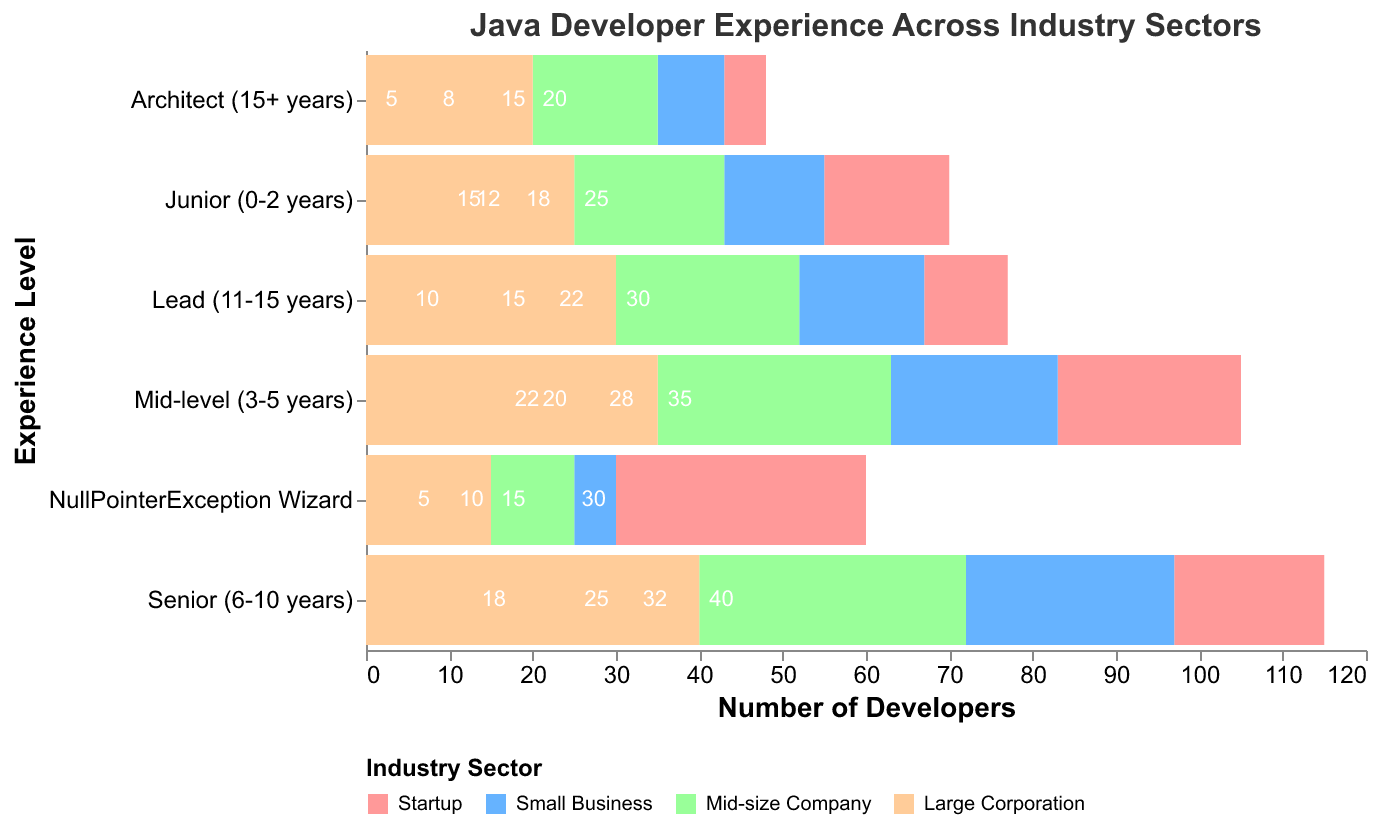How many experience levels are shown in the figure? There are six experience levels listed along the y-axis: Junior (0-2 years), Mid-level (3-5 years), Senior (6-10 years), Lead (11-15 years), Architect (15+ years), and NullPointerException Wizard.
Answer: Six Which industry sector has the highest number of Senior (6-10 years) Java developers? By observing the bar lengths for Senior Java developers, the bar for Large Corporation is the longest, indicating the highest count.
Answer: Large Corporation Compared to Small Businesses, how many more Mid-level (3-5 years) Java developers are there in mid-size companies? The number of Mid-level developers in Small Businesses is 20, and in Mid-size Companies is 28. The difference is 28 - 20 = 8.
Answer: 8 Among NullPointerException Wizards, which industry sector has the lowest number of Java developers? Observing the bars for NullPointerException Wizards, the Starter companies have the lowest count with -30 (negative because it's on the left side).
Answer: Startup Does any experience level have more developers in Startups than in Small Businesses? If yes, which one(s)? Comparing each experience level between Startups and Small Businesses, none of the levels has more developers in Startups.
Answer: No For Lead (11-15 years) Java developers, what is the combined number of developers in Mid-size Company and Large Corporation? Adding up the numbers for Lead developers: 22 (Mid-size Company) + 30 (Large Corporation) = 22 + 30 = 52.
Answer: 52 